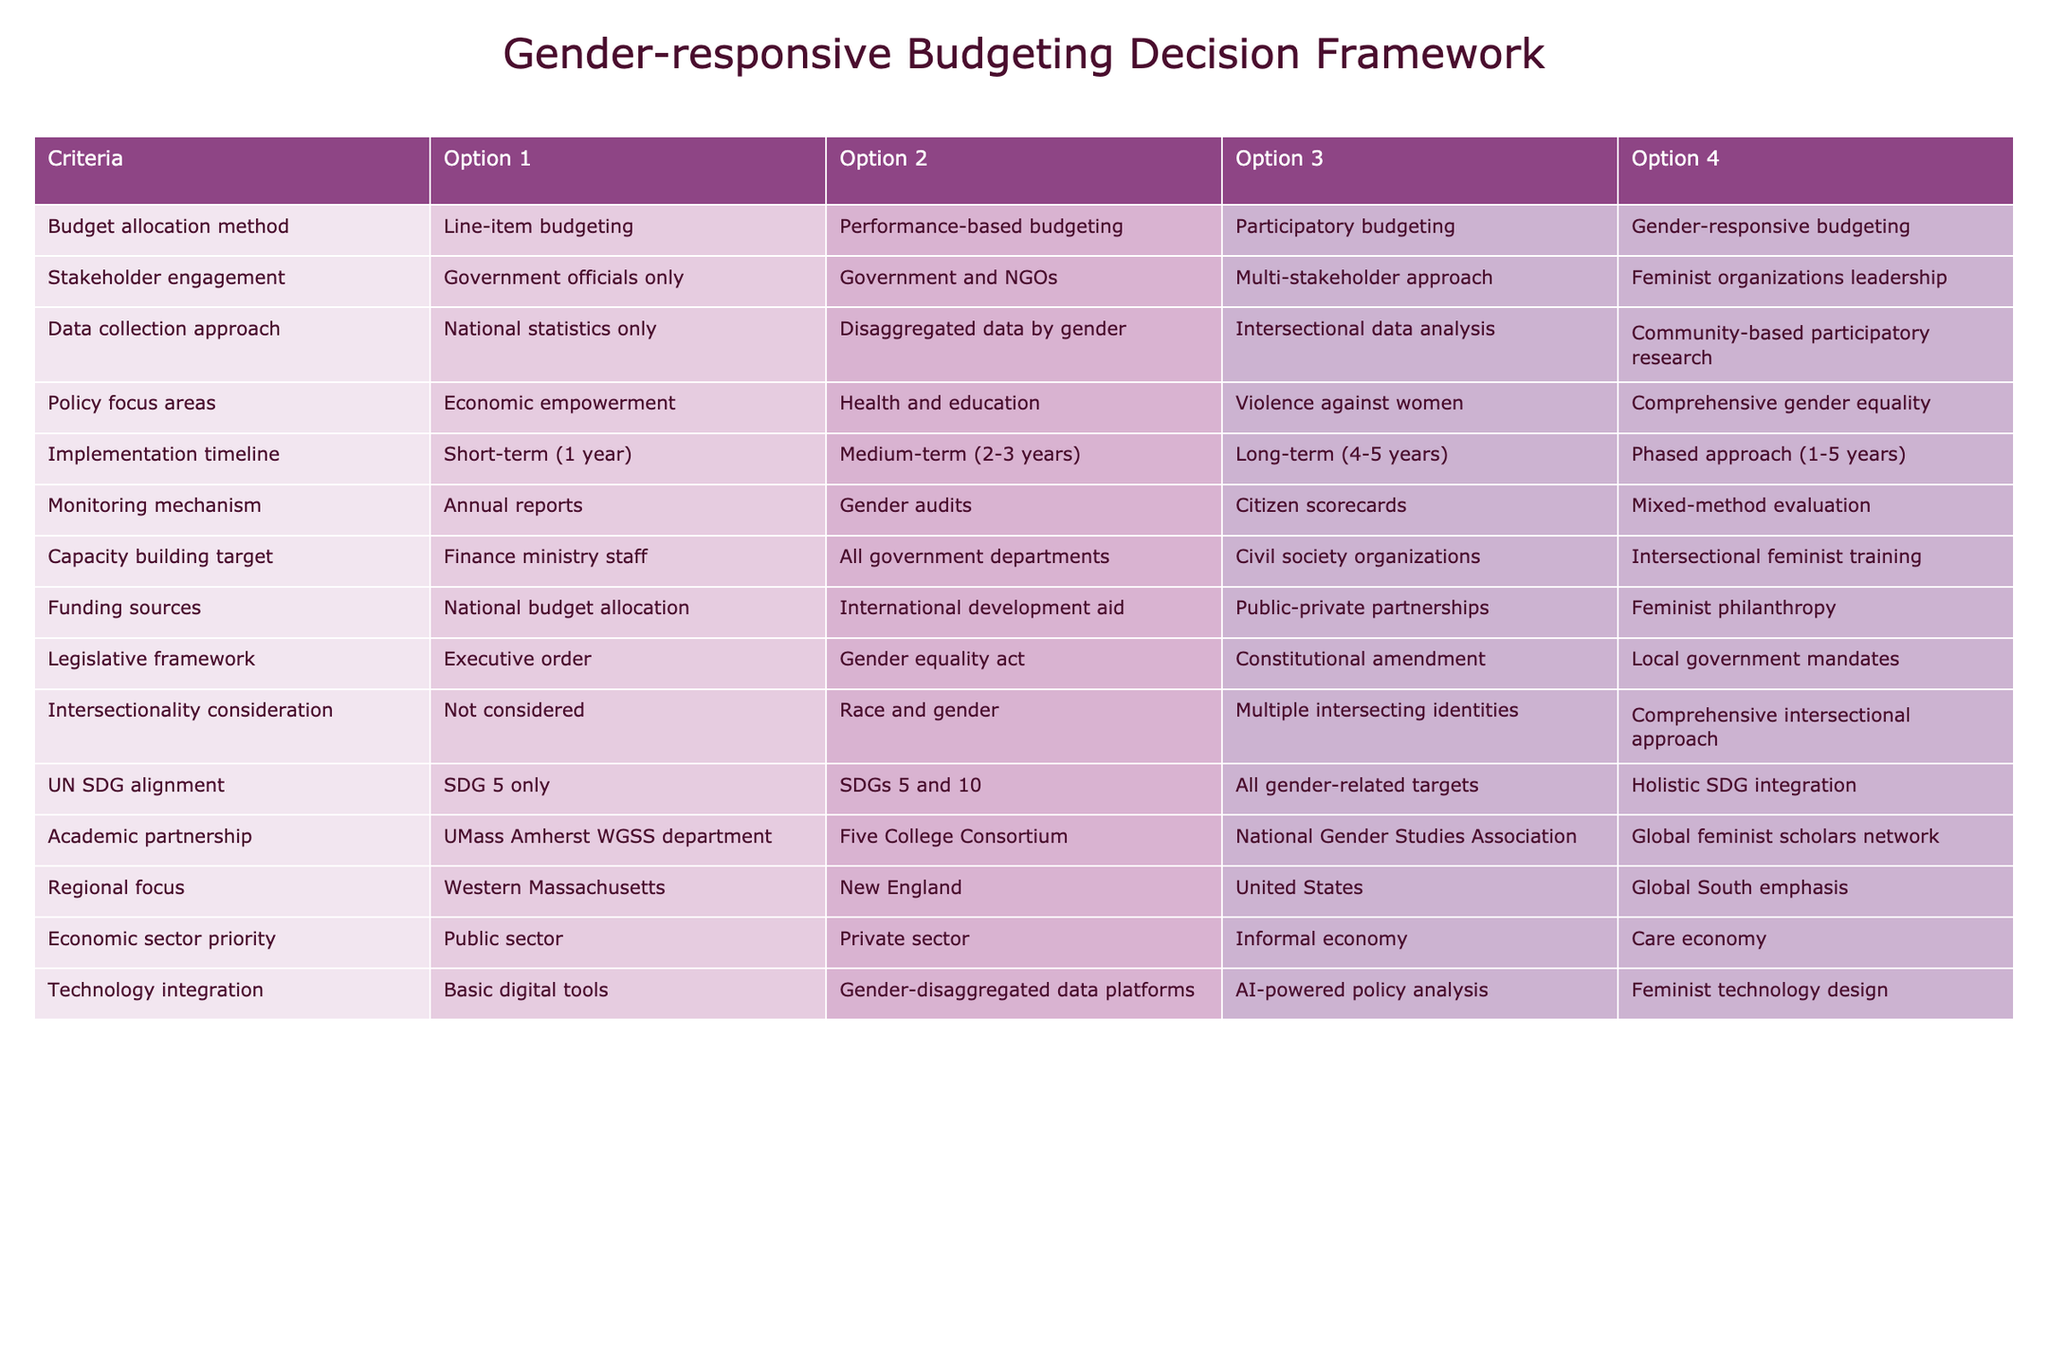What is the budget allocation method that focuses on gender? According to the table, the option for budget allocation that is specifically focused on gender is "Gender-responsive budgeting."
Answer: Gender-responsive budgeting Which approach involves community participation in data collection? The table indicates that "Community-based participatory research" is the option that emphasizes community involvement in the data collection process.
Answer: Community-based participatory research Is the economic sector priority that highlights the care economy? The table shows that "Care economy" is listed as one of the options under economic sector priority, which indicates that it does indeed highlight the care economy.
Answer: Yes What is the monitoring mechanism that uses a combination of methods? From the table, "Mixed-method evaluation" is identified as the monitoring mechanism that employs a combination of both qualitative and quantitative methods.
Answer: Mixed-method evaluation What are the legislative frameworks available for gender-responsive budgeting? List any two. The table provides four options; two of them are "Gender equality act" and "Local government mandates." These are the frameworks available for gender-responsive budgeting.
Answer: Gender equality act, Local government mandates Which data collection approach takes into account multiple intersecting identities? The table lists "Comprehensive intersectional approach" as the data collection method that considers multiple intersecting identities.
Answer: Comprehensive intersectional approach What is the average monitoring mechanism type listed in the table? There are four monitoring mechanism types: annual reports, gender audits, citizen scorecards, and mixed-method evaluation. To find the average, we sum these options but since they are qualitative, we will note that "Mixed-method evaluation" provides a more balanced and comprehensive monitoring mechanism compared to the rest.
Answer: Mixed-method evaluation Which stakeholder engagement option focuses on feminist organizations? As per the table, the stakeholder engagement option that involves feminist organizations is labeled "Feminist organizations leadership."
Answer: Feminist organizations leadership Is the funding source that emphasizes feminist philanthropy available? The table confirms that "Feminist philanthropy" is listed as one of the funding sources for gender-responsive budgeting.
Answer: Yes 